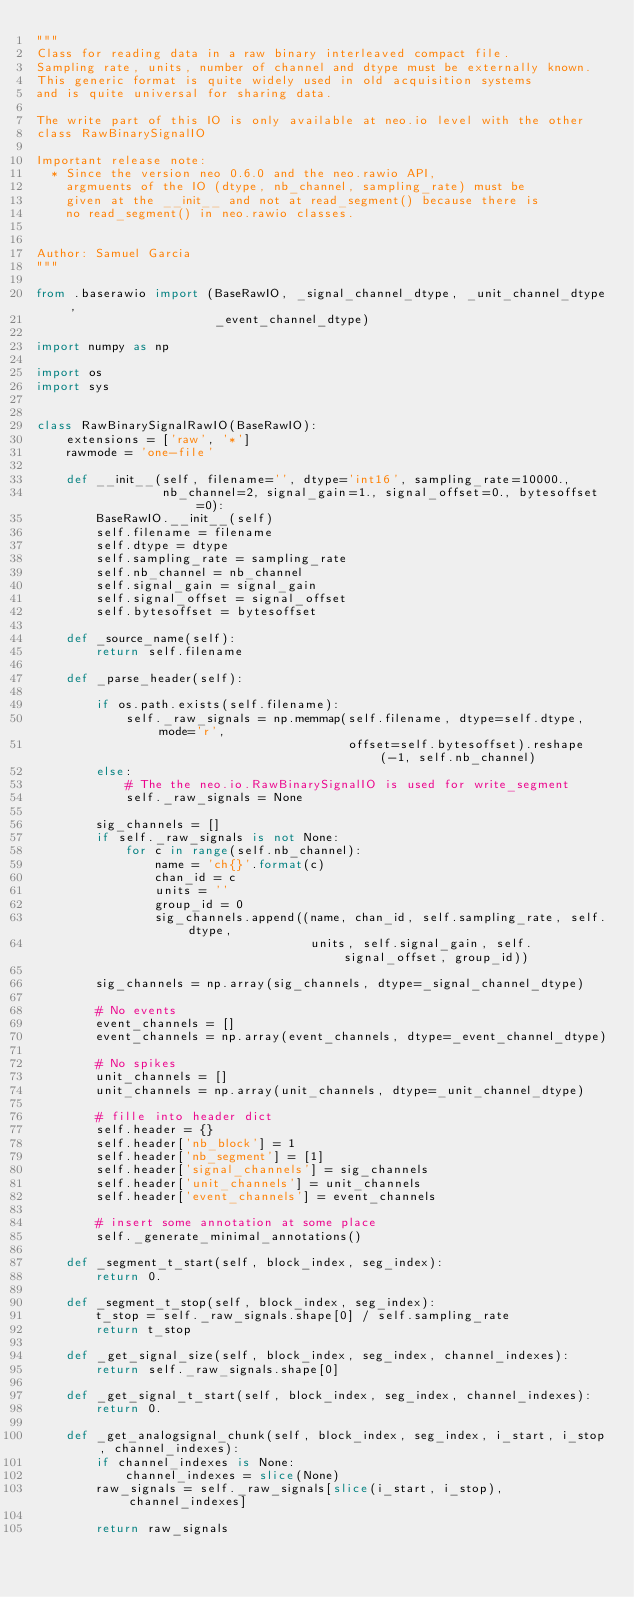Convert code to text. <code><loc_0><loc_0><loc_500><loc_500><_Python_>"""
Class for reading data in a raw binary interleaved compact file.
Sampling rate, units, number of channel and dtype must be externally known.
This generic format is quite widely used in old acquisition systems
and is quite universal for sharing data.

The write part of this IO is only available at neo.io level with the other
class RawBinarySignalIO

Important release note:
  * Since the version neo 0.6.0 and the neo.rawio API,
    argmuents of the IO (dtype, nb_channel, sampling_rate) must be
    given at the __init__ and not at read_segment() because there is
    no read_segment() in neo.rawio classes.


Author: Samuel Garcia
"""

from .baserawio import (BaseRawIO, _signal_channel_dtype, _unit_channel_dtype,
                        _event_channel_dtype)

import numpy as np

import os
import sys


class RawBinarySignalRawIO(BaseRawIO):
    extensions = ['raw', '*']
    rawmode = 'one-file'

    def __init__(self, filename='', dtype='int16', sampling_rate=10000.,
                 nb_channel=2, signal_gain=1., signal_offset=0., bytesoffset=0):
        BaseRawIO.__init__(self)
        self.filename = filename
        self.dtype = dtype
        self.sampling_rate = sampling_rate
        self.nb_channel = nb_channel
        self.signal_gain = signal_gain
        self.signal_offset = signal_offset
        self.bytesoffset = bytesoffset

    def _source_name(self):
        return self.filename

    def _parse_header(self):

        if os.path.exists(self.filename):
            self._raw_signals = np.memmap(self.filename, dtype=self.dtype, mode='r',
                                          offset=self.bytesoffset).reshape(-1, self.nb_channel)
        else:
            # The the neo.io.RawBinarySignalIO is used for write_segment
            self._raw_signals = None

        sig_channels = []
        if self._raw_signals is not None:
            for c in range(self.nb_channel):
                name = 'ch{}'.format(c)
                chan_id = c
                units = ''
                group_id = 0
                sig_channels.append((name, chan_id, self.sampling_rate, self.dtype,
                                     units, self.signal_gain, self.signal_offset, group_id))

        sig_channels = np.array(sig_channels, dtype=_signal_channel_dtype)

        # No events
        event_channels = []
        event_channels = np.array(event_channels, dtype=_event_channel_dtype)

        # No spikes
        unit_channels = []
        unit_channels = np.array(unit_channels, dtype=_unit_channel_dtype)

        # fille into header dict
        self.header = {}
        self.header['nb_block'] = 1
        self.header['nb_segment'] = [1]
        self.header['signal_channels'] = sig_channels
        self.header['unit_channels'] = unit_channels
        self.header['event_channels'] = event_channels

        # insert some annotation at some place
        self._generate_minimal_annotations()

    def _segment_t_start(self, block_index, seg_index):
        return 0.

    def _segment_t_stop(self, block_index, seg_index):
        t_stop = self._raw_signals.shape[0] / self.sampling_rate
        return t_stop

    def _get_signal_size(self, block_index, seg_index, channel_indexes):
        return self._raw_signals.shape[0]

    def _get_signal_t_start(self, block_index, seg_index, channel_indexes):
        return 0.

    def _get_analogsignal_chunk(self, block_index, seg_index, i_start, i_stop, channel_indexes):
        if channel_indexes is None:
            channel_indexes = slice(None)
        raw_signals = self._raw_signals[slice(i_start, i_stop), channel_indexes]

        return raw_signals
</code> 